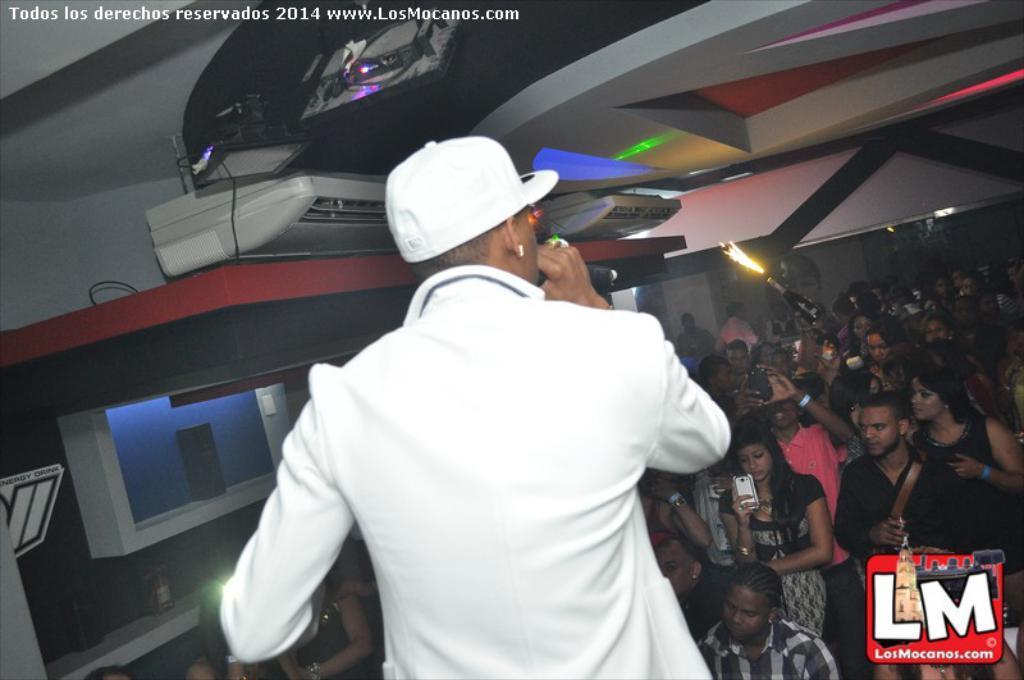Please provide a concise description of this image. This picture describes about group of people, in the middle of the image we can see a man, he wore a cap and he is holding a microphone, in the background we can see few lights and a bottle, at the bottom of the image we can see a logo, on top of the image we can find some text. 